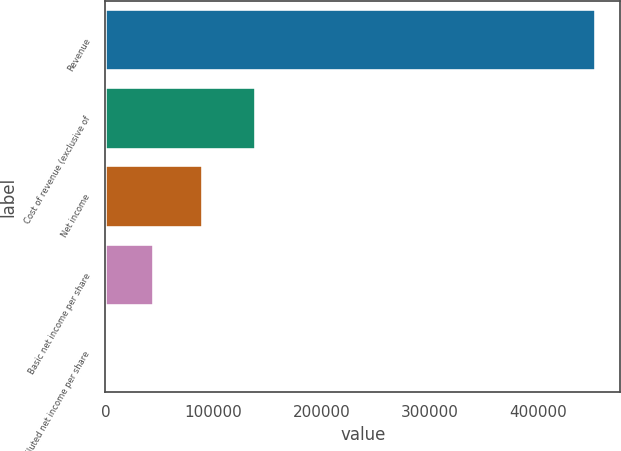<chart> <loc_0><loc_0><loc_500><loc_500><bar_chart><fcel>Revenue<fcel>Cost of revenue (exclusive of<fcel>Net income<fcel>Basic net income per share<fcel>Diluted net income per share<nl><fcel>453502<fcel>139612<fcel>90700.7<fcel>45350.6<fcel>0.4<nl></chart> 